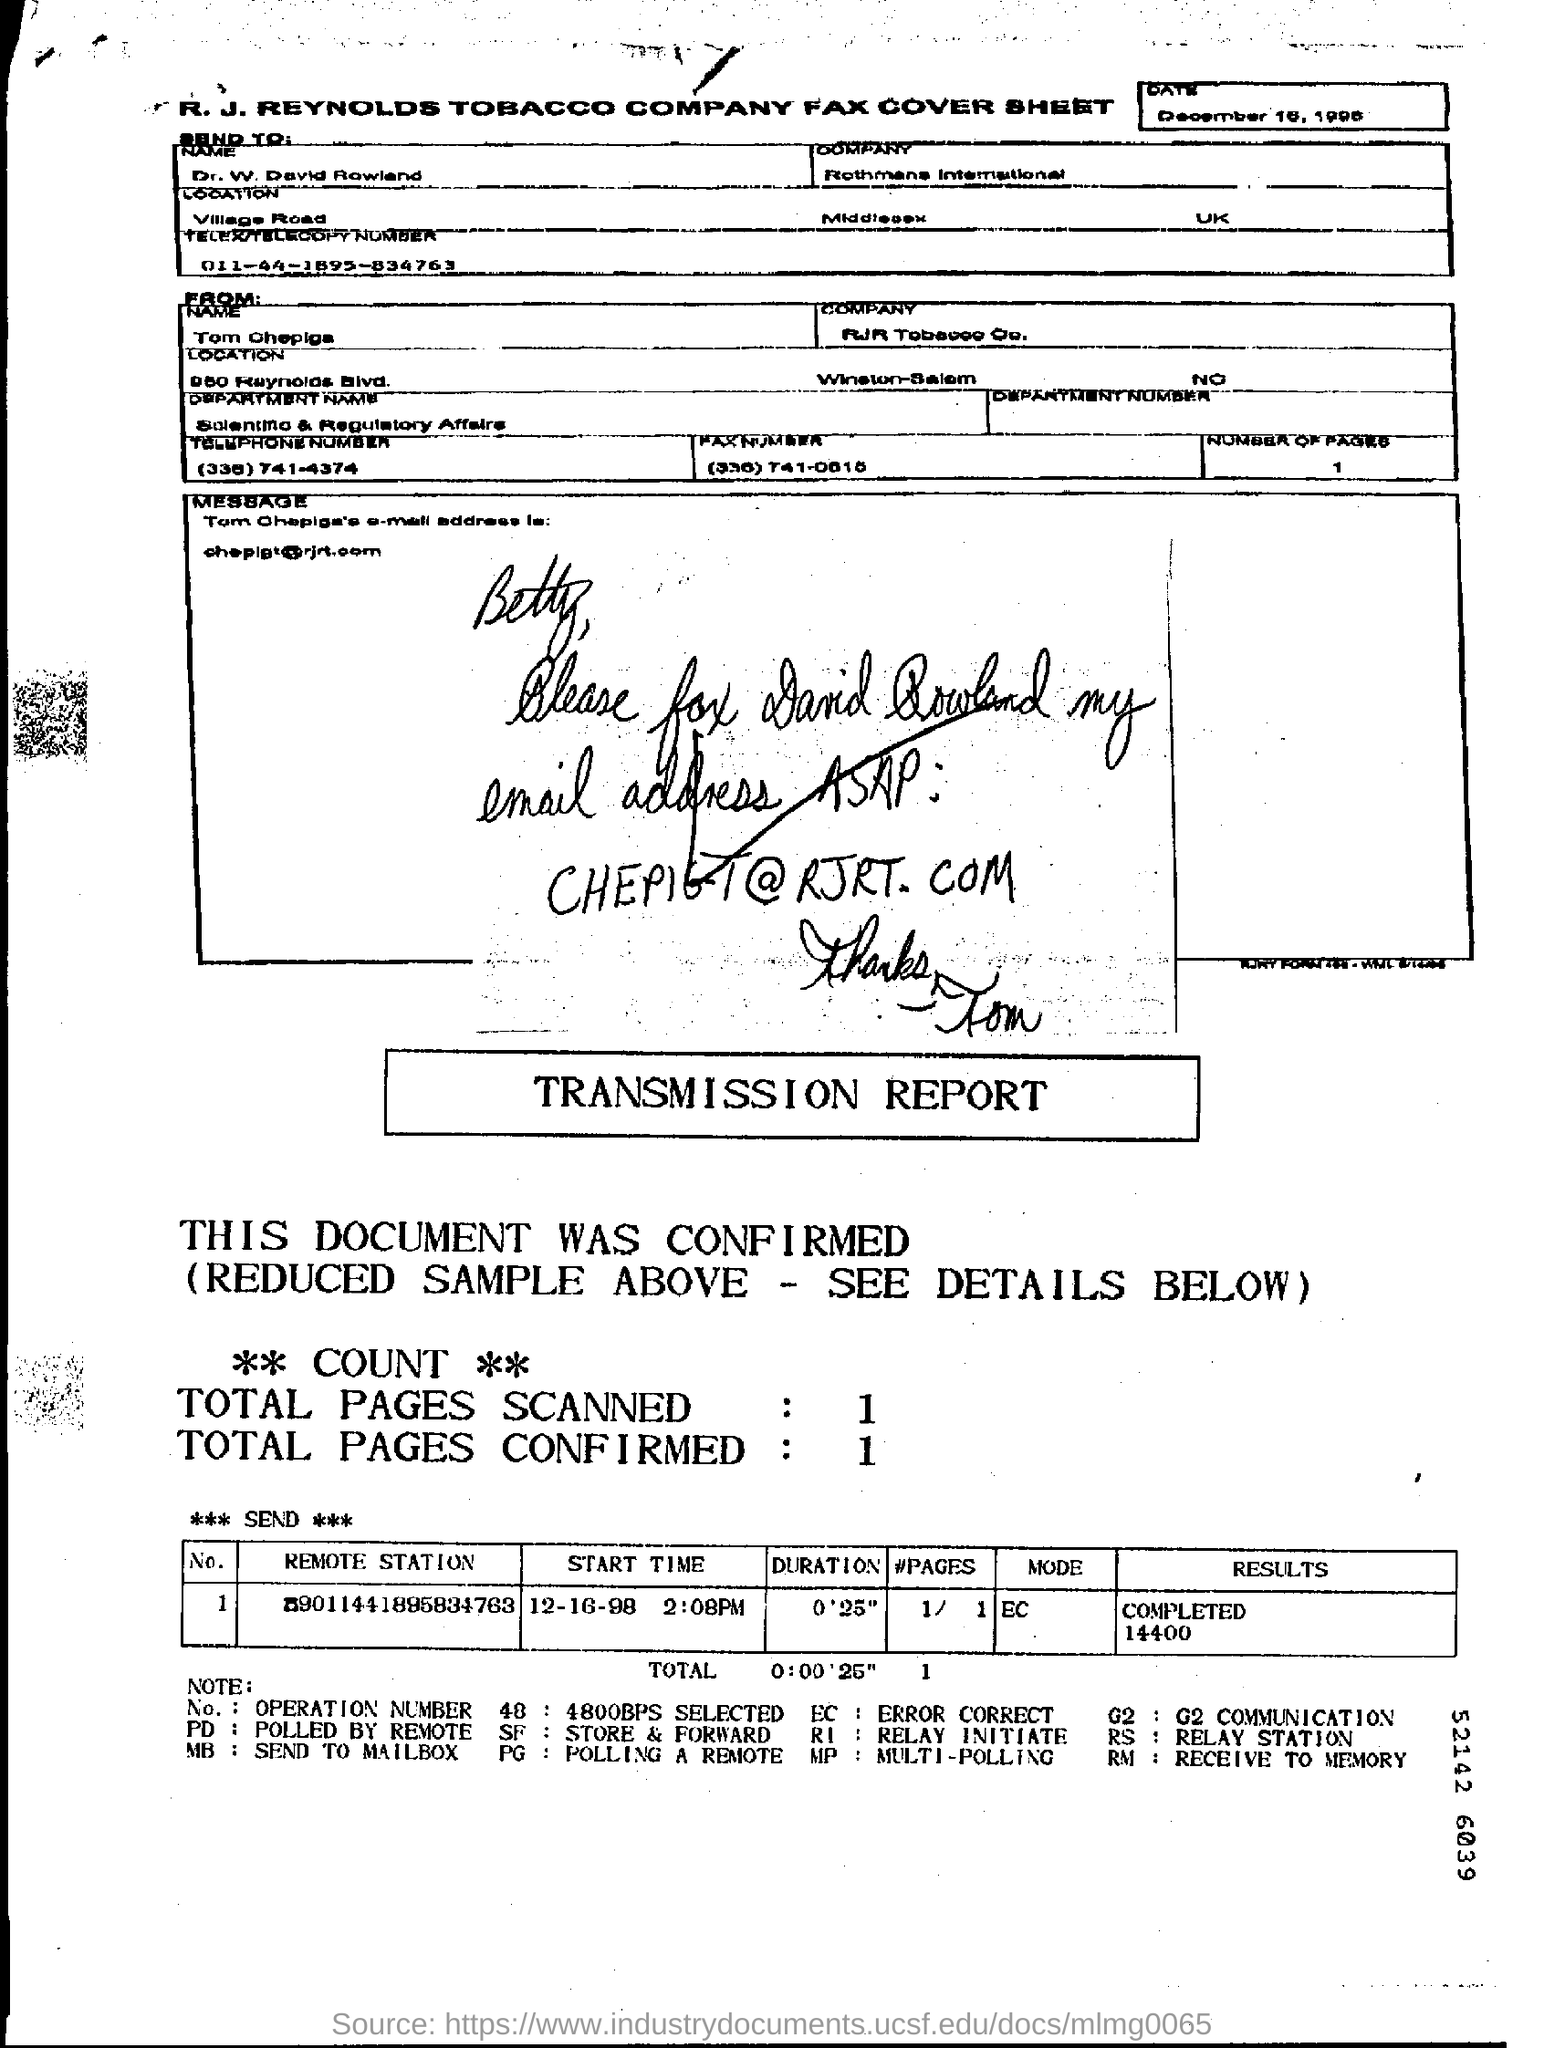What are the Total Pages Confirmed? The total number of pages confirmed is 1, as indicated in the 'TOTAL PAGES CONFIRMED' section of the fax transmission report. 